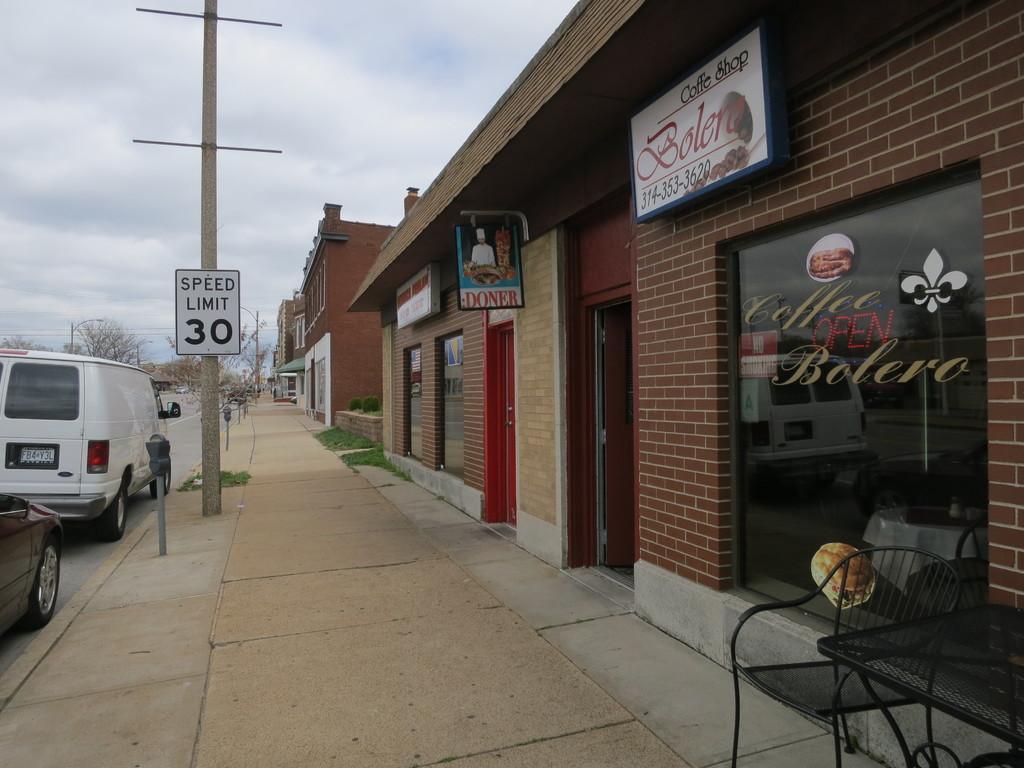Describe this image in one or two sentences. At the top we can see sky with clouds. These are stores. Near to the stores we can see a chair and a table. These are plants. We can see vehicles on the road here. These are bare trees. 